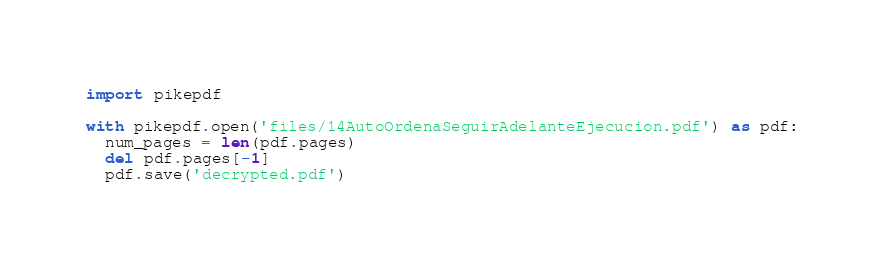Convert code to text. <code><loc_0><loc_0><loc_500><loc_500><_Python_>import pikepdf

with pikepdf.open('files/14AutoOrdenaSeguirAdelanteEjecucion.pdf') as pdf:
  num_pages = len(pdf.pages)
  del pdf.pages[-1]
  pdf.save('decrypted.pdf')</code> 